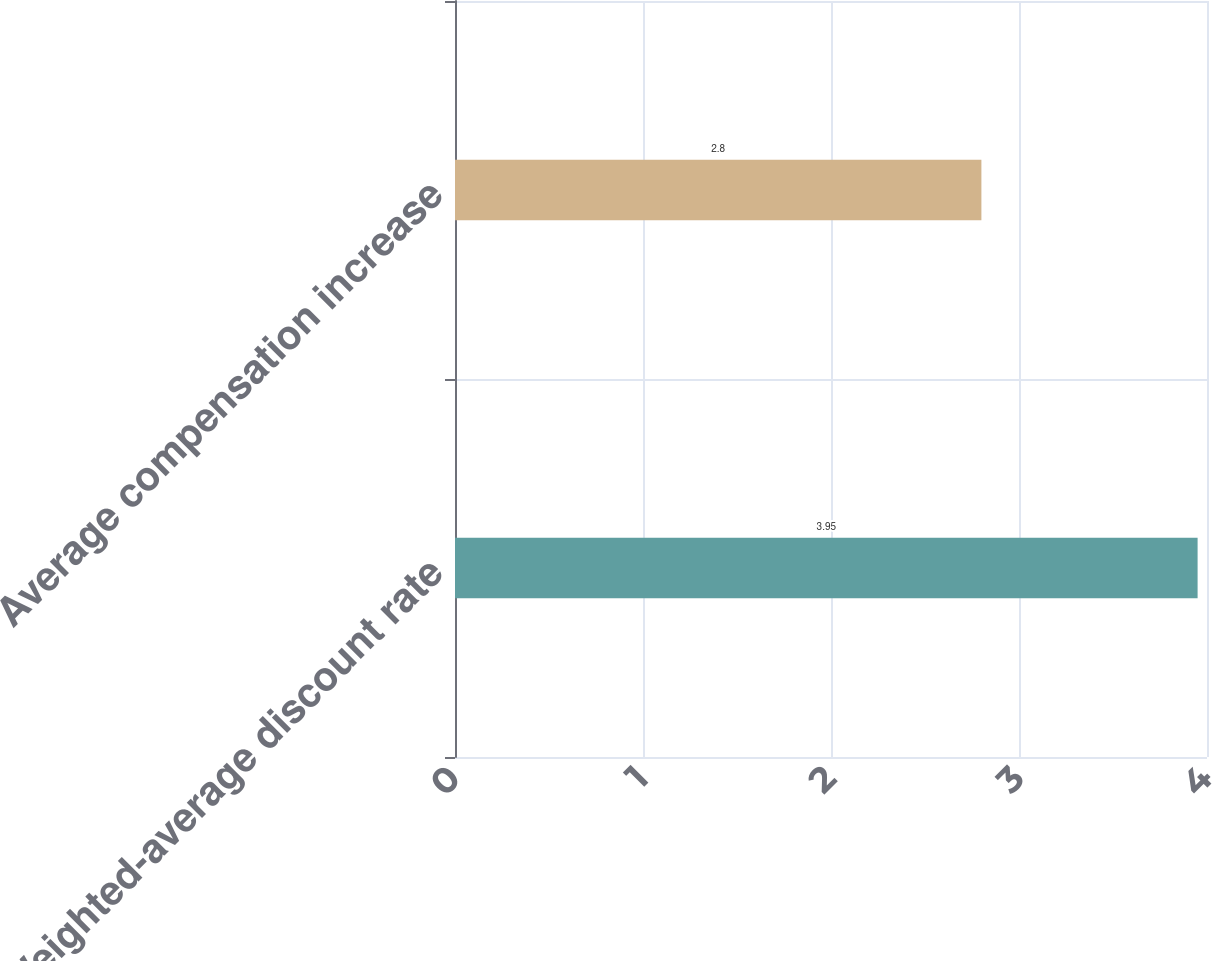Convert chart. <chart><loc_0><loc_0><loc_500><loc_500><bar_chart><fcel>Weighted-average discount rate<fcel>Average compensation increase<nl><fcel>3.95<fcel>2.8<nl></chart> 